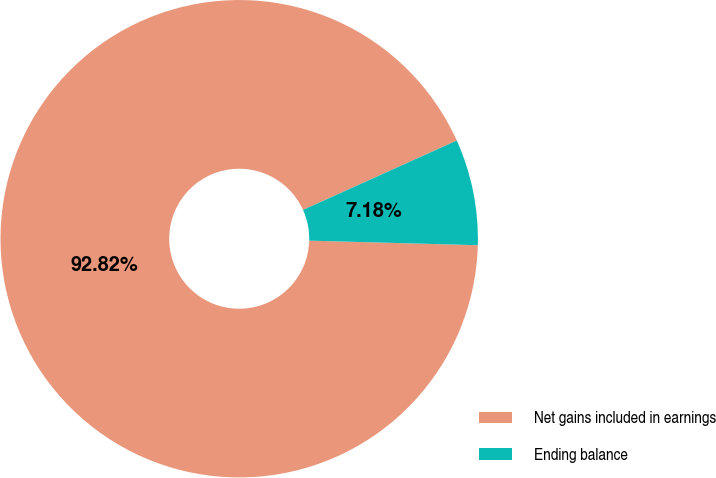Convert chart to OTSL. <chart><loc_0><loc_0><loc_500><loc_500><pie_chart><fcel>Net gains included in earnings<fcel>Ending balance<nl><fcel>92.82%<fcel>7.18%<nl></chart> 